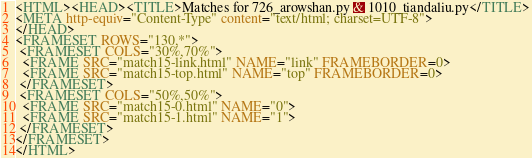Convert code to text. <code><loc_0><loc_0><loc_500><loc_500><_HTML_><HTML><HEAD><TITLE>Matches for 726_arowshan.py & 1010_tiandaliu.py</TITLE>
<META http-equiv="Content-Type" content="text/html; charset=UTF-8">
</HEAD>
<FRAMESET ROWS="130,*">
 <FRAMESET COLS="30%,70%">
  <FRAME SRC="match15-link.html" NAME="link" FRAMEBORDER=0>
  <FRAME SRC="match15-top.html" NAME="top" FRAMEBORDER=0>
 </FRAMESET>
 <FRAMESET COLS="50%,50%">
  <FRAME SRC="match15-0.html" NAME="0">
  <FRAME SRC="match15-1.html" NAME="1">
 </FRAMESET>
</FRAMESET>
</HTML>
</code> 